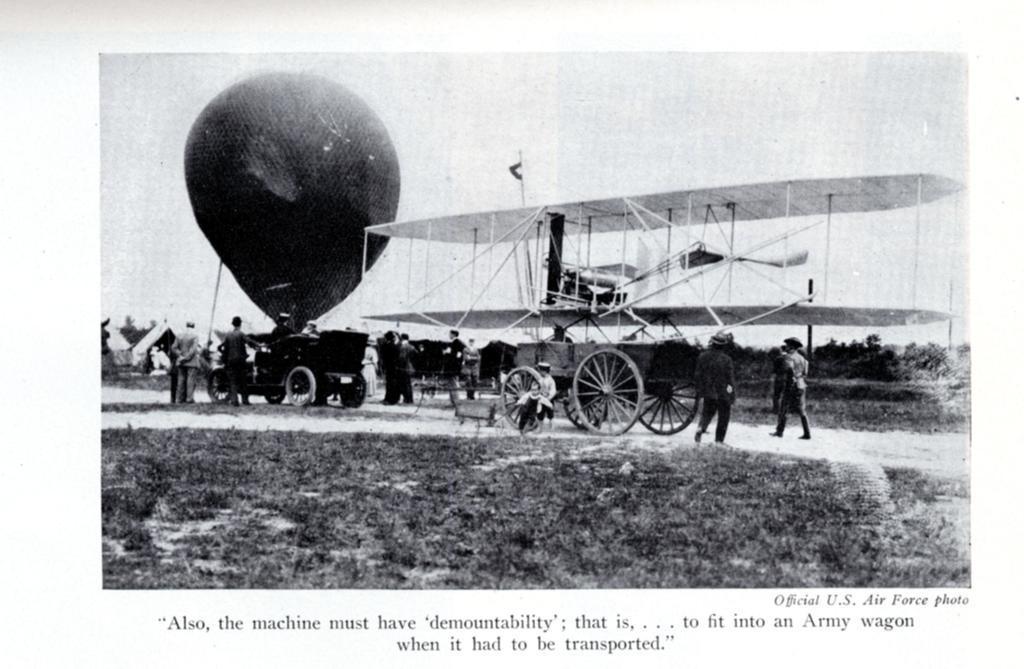Describe this image in one or two sentences. This is a black and white image. In this image we can see an aeroplane, cart, parachute, persons and sky. 